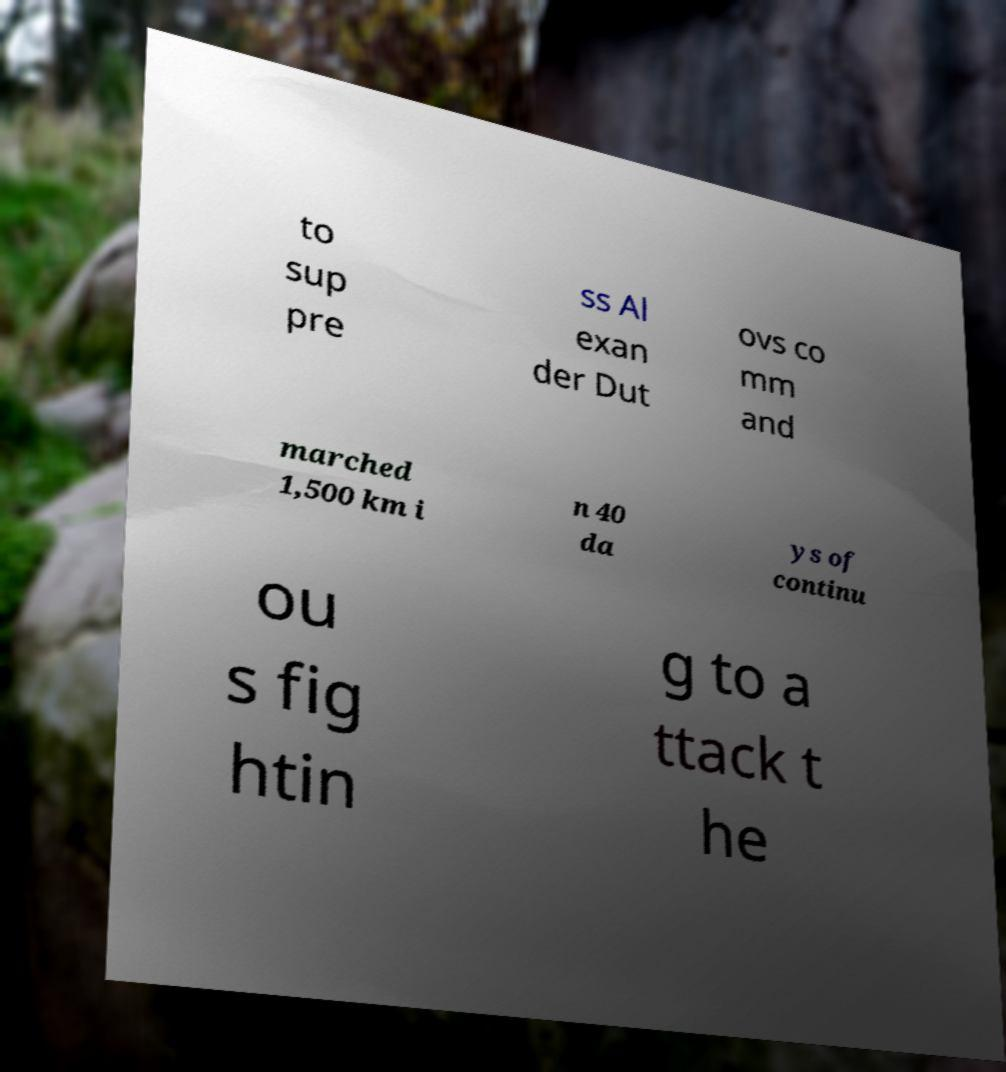Can you read and provide the text displayed in the image?This photo seems to have some interesting text. Can you extract and type it out for me? to sup pre ss Al exan der Dut ovs co mm and marched 1,500 km i n 40 da ys of continu ou s fig htin g to a ttack t he 